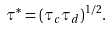Convert formula to latex. <formula><loc_0><loc_0><loc_500><loc_500>\tau ^ { * } = ( \tau _ { c } \tau _ { d } ) ^ { 1 / 2 } .</formula> 